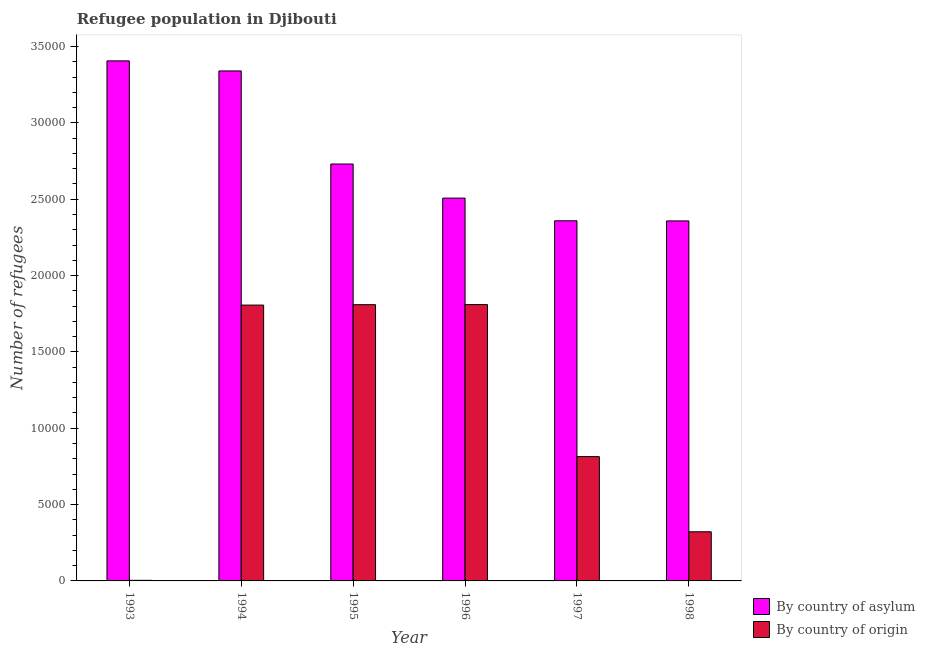How many different coloured bars are there?
Your answer should be compact. 2. Are the number of bars on each tick of the X-axis equal?
Your answer should be compact. Yes. How many bars are there on the 1st tick from the left?
Provide a short and direct response. 2. How many bars are there on the 5th tick from the right?
Give a very brief answer. 2. What is the number of refugees by country of asylum in 1998?
Make the answer very short. 2.36e+04. Across all years, what is the maximum number of refugees by country of origin?
Your response must be concise. 1.81e+04. Across all years, what is the minimum number of refugees by country of asylum?
Keep it short and to the point. 2.36e+04. In which year was the number of refugees by country of asylum minimum?
Offer a very short reply. 1998. What is the total number of refugees by country of asylum in the graph?
Ensure brevity in your answer.  1.67e+05. What is the difference between the number of refugees by country of asylum in 1994 and that in 1996?
Your answer should be compact. 8330. What is the difference between the number of refugees by country of asylum in 1996 and the number of refugees by country of origin in 1998?
Your response must be concise. 1494. What is the average number of refugees by country of asylum per year?
Your response must be concise. 2.78e+04. In the year 1995, what is the difference between the number of refugees by country of asylum and number of refugees by country of origin?
Keep it short and to the point. 0. What is the ratio of the number of refugees by country of asylum in 1996 to that in 1997?
Provide a succinct answer. 1.06. What is the difference between the highest and the second highest number of refugees by country of asylum?
Offer a terse response. 659. What is the difference between the highest and the lowest number of refugees by country of asylum?
Offer a terse response. 1.05e+04. Is the sum of the number of refugees by country of origin in 1995 and 1998 greater than the maximum number of refugees by country of asylum across all years?
Offer a very short reply. Yes. What does the 2nd bar from the left in 1994 represents?
Provide a short and direct response. By country of origin. What does the 1st bar from the right in 1995 represents?
Provide a succinct answer. By country of origin. Where does the legend appear in the graph?
Make the answer very short. Bottom right. How many legend labels are there?
Your answer should be very brief. 2. What is the title of the graph?
Offer a terse response. Refugee population in Djibouti. What is the label or title of the Y-axis?
Your answer should be compact. Number of refugees. What is the Number of refugees in By country of asylum in 1993?
Keep it short and to the point. 3.41e+04. What is the Number of refugees of By country of origin in 1993?
Give a very brief answer. 38. What is the Number of refugees of By country of asylum in 1994?
Ensure brevity in your answer.  3.34e+04. What is the Number of refugees in By country of origin in 1994?
Make the answer very short. 1.81e+04. What is the Number of refugees of By country of asylum in 1995?
Your answer should be very brief. 2.73e+04. What is the Number of refugees in By country of origin in 1995?
Your response must be concise. 1.81e+04. What is the Number of refugees of By country of asylum in 1996?
Provide a short and direct response. 2.51e+04. What is the Number of refugees of By country of origin in 1996?
Make the answer very short. 1.81e+04. What is the Number of refugees of By country of asylum in 1997?
Provide a succinct answer. 2.36e+04. What is the Number of refugees in By country of origin in 1997?
Provide a succinct answer. 8142. What is the Number of refugees of By country of asylum in 1998?
Offer a terse response. 2.36e+04. What is the Number of refugees in By country of origin in 1998?
Offer a terse response. 3219. Across all years, what is the maximum Number of refugees in By country of asylum?
Offer a terse response. 3.41e+04. Across all years, what is the maximum Number of refugees of By country of origin?
Provide a short and direct response. 1.81e+04. Across all years, what is the minimum Number of refugees in By country of asylum?
Your answer should be compact. 2.36e+04. Across all years, what is the minimum Number of refugees in By country of origin?
Your answer should be compact. 38. What is the total Number of refugees in By country of asylum in the graph?
Make the answer very short. 1.67e+05. What is the total Number of refugees of By country of origin in the graph?
Offer a very short reply. 6.57e+04. What is the difference between the Number of refugees in By country of asylum in 1993 and that in 1994?
Provide a short and direct response. 659. What is the difference between the Number of refugees in By country of origin in 1993 and that in 1994?
Provide a succinct answer. -1.80e+04. What is the difference between the Number of refugees of By country of asylum in 1993 and that in 1995?
Provide a short and direct response. 6755. What is the difference between the Number of refugees of By country of origin in 1993 and that in 1995?
Keep it short and to the point. -1.81e+04. What is the difference between the Number of refugees of By country of asylum in 1993 and that in 1996?
Provide a short and direct response. 8989. What is the difference between the Number of refugees in By country of origin in 1993 and that in 1996?
Give a very brief answer. -1.81e+04. What is the difference between the Number of refugees in By country of asylum in 1993 and that in 1997?
Provide a short and direct response. 1.05e+04. What is the difference between the Number of refugees of By country of origin in 1993 and that in 1997?
Your response must be concise. -8104. What is the difference between the Number of refugees in By country of asylum in 1993 and that in 1998?
Offer a very short reply. 1.05e+04. What is the difference between the Number of refugees of By country of origin in 1993 and that in 1998?
Make the answer very short. -3181. What is the difference between the Number of refugees in By country of asylum in 1994 and that in 1995?
Offer a terse response. 6096. What is the difference between the Number of refugees of By country of origin in 1994 and that in 1995?
Keep it short and to the point. -27. What is the difference between the Number of refugees in By country of asylum in 1994 and that in 1996?
Make the answer very short. 8330. What is the difference between the Number of refugees in By country of origin in 1994 and that in 1996?
Provide a succinct answer. -33. What is the difference between the Number of refugees of By country of asylum in 1994 and that in 1997?
Make the answer very short. 9816. What is the difference between the Number of refugees of By country of origin in 1994 and that in 1997?
Provide a short and direct response. 9926. What is the difference between the Number of refugees in By country of asylum in 1994 and that in 1998?
Provide a short and direct response. 9824. What is the difference between the Number of refugees in By country of origin in 1994 and that in 1998?
Ensure brevity in your answer.  1.48e+04. What is the difference between the Number of refugees in By country of asylum in 1995 and that in 1996?
Provide a succinct answer. 2234. What is the difference between the Number of refugees in By country of origin in 1995 and that in 1996?
Your answer should be compact. -6. What is the difference between the Number of refugees of By country of asylum in 1995 and that in 1997?
Keep it short and to the point. 3720. What is the difference between the Number of refugees of By country of origin in 1995 and that in 1997?
Your response must be concise. 9953. What is the difference between the Number of refugees in By country of asylum in 1995 and that in 1998?
Give a very brief answer. 3728. What is the difference between the Number of refugees of By country of origin in 1995 and that in 1998?
Your answer should be compact. 1.49e+04. What is the difference between the Number of refugees in By country of asylum in 1996 and that in 1997?
Provide a succinct answer. 1486. What is the difference between the Number of refugees of By country of origin in 1996 and that in 1997?
Your answer should be compact. 9959. What is the difference between the Number of refugees of By country of asylum in 1996 and that in 1998?
Make the answer very short. 1494. What is the difference between the Number of refugees of By country of origin in 1996 and that in 1998?
Provide a short and direct response. 1.49e+04. What is the difference between the Number of refugees of By country of origin in 1997 and that in 1998?
Provide a short and direct response. 4923. What is the difference between the Number of refugees in By country of asylum in 1993 and the Number of refugees in By country of origin in 1994?
Make the answer very short. 1.60e+04. What is the difference between the Number of refugees of By country of asylum in 1993 and the Number of refugees of By country of origin in 1995?
Offer a very short reply. 1.60e+04. What is the difference between the Number of refugees of By country of asylum in 1993 and the Number of refugees of By country of origin in 1996?
Make the answer very short. 1.60e+04. What is the difference between the Number of refugees of By country of asylum in 1993 and the Number of refugees of By country of origin in 1997?
Give a very brief answer. 2.59e+04. What is the difference between the Number of refugees in By country of asylum in 1993 and the Number of refugees in By country of origin in 1998?
Your answer should be very brief. 3.08e+04. What is the difference between the Number of refugees in By country of asylum in 1994 and the Number of refugees in By country of origin in 1995?
Your response must be concise. 1.53e+04. What is the difference between the Number of refugees of By country of asylum in 1994 and the Number of refugees of By country of origin in 1996?
Your answer should be very brief. 1.53e+04. What is the difference between the Number of refugees in By country of asylum in 1994 and the Number of refugees in By country of origin in 1997?
Provide a succinct answer. 2.53e+04. What is the difference between the Number of refugees in By country of asylum in 1994 and the Number of refugees in By country of origin in 1998?
Offer a very short reply. 3.02e+04. What is the difference between the Number of refugees of By country of asylum in 1995 and the Number of refugees of By country of origin in 1996?
Your response must be concise. 9209. What is the difference between the Number of refugees in By country of asylum in 1995 and the Number of refugees in By country of origin in 1997?
Your response must be concise. 1.92e+04. What is the difference between the Number of refugees of By country of asylum in 1995 and the Number of refugees of By country of origin in 1998?
Provide a succinct answer. 2.41e+04. What is the difference between the Number of refugees in By country of asylum in 1996 and the Number of refugees in By country of origin in 1997?
Provide a short and direct response. 1.69e+04. What is the difference between the Number of refugees of By country of asylum in 1996 and the Number of refugees of By country of origin in 1998?
Provide a succinct answer. 2.19e+04. What is the difference between the Number of refugees in By country of asylum in 1997 and the Number of refugees in By country of origin in 1998?
Give a very brief answer. 2.04e+04. What is the average Number of refugees in By country of asylum per year?
Keep it short and to the point. 2.78e+04. What is the average Number of refugees in By country of origin per year?
Your answer should be compact. 1.09e+04. In the year 1993, what is the difference between the Number of refugees in By country of asylum and Number of refugees in By country of origin?
Your answer should be very brief. 3.40e+04. In the year 1994, what is the difference between the Number of refugees in By country of asylum and Number of refugees in By country of origin?
Ensure brevity in your answer.  1.53e+04. In the year 1995, what is the difference between the Number of refugees in By country of asylum and Number of refugees in By country of origin?
Your answer should be very brief. 9215. In the year 1996, what is the difference between the Number of refugees in By country of asylum and Number of refugees in By country of origin?
Offer a terse response. 6975. In the year 1997, what is the difference between the Number of refugees of By country of asylum and Number of refugees of By country of origin?
Give a very brief answer. 1.54e+04. In the year 1998, what is the difference between the Number of refugees in By country of asylum and Number of refugees in By country of origin?
Give a very brief answer. 2.04e+04. What is the ratio of the Number of refugees in By country of asylum in 1993 to that in 1994?
Make the answer very short. 1.02. What is the ratio of the Number of refugees of By country of origin in 1993 to that in 1994?
Your response must be concise. 0. What is the ratio of the Number of refugees of By country of asylum in 1993 to that in 1995?
Provide a short and direct response. 1.25. What is the ratio of the Number of refugees of By country of origin in 1993 to that in 1995?
Offer a very short reply. 0. What is the ratio of the Number of refugees in By country of asylum in 1993 to that in 1996?
Provide a succinct answer. 1.36. What is the ratio of the Number of refugees of By country of origin in 1993 to that in 1996?
Your answer should be very brief. 0. What is the ratio of the Number of refugees in By country of asylum in 1993 to that in 1997?
Offer a terse response. 1.44. What is the ratio of the Number of refugees in By country of origin in 1993 to that in 1997?
Your response must be concise. 0. What is the ratio of the Number of refugees in By country of asylum in 1993 to that in 1998?
Keep it short and to the point. 1.44. What is the ratio of the Number of refugees of By country of origin in 1993 to that in 1998?
Keep it short and to the point. 0.01. What is the ratio of the Number of refugees in By country of asylum in 1994 to that in 1995?
Your response must be concise. 1.22. What is the ratio of the Number of refugees in By country of asylum in 1994 to that in 1996?
Offer a very short reply. 1.33. What is the ratio of the Number of refugees in By country of asylum in 1994 to that in 1997?
Your answer should be very brief. 1.42. What is the ratio of the Number of refugees in By country of origin in 1994 to that in 1997?
Your response must be concise. 2.22. What is the ratio of the Number of refugees of By country of asylum in 1994 to that in 1998?
Offer a terse response. 1.42. What is the ratio of the Number of refugees of By country of origin in 1994 to that in 1998?
Provide a short and direct response. 5.61. What is the ratio of the Number of refugees in By country of asylum in 1995 to that in 1996?
Give a very brief answer. 1.09. What is the ratio of the Number of refugees of By country of origin in 1995 to that in 1996?
Offer a very short reply. 1. What is the ratio of the Number of refugees of By country of asylum in 1995 to that in 1997?
Provide a succinct answer. 1.16. What is the ratio of the Number of refugees in By country of origin in 1995 to that in 1997?
Your answer should be compact. 2.22. What is the ratio of the Number of refugees of By country of asylum in 1995 to that in 1998?
Keep it short and to the point. 1.16. What is the ratio of the Number of refugees of By country of origin in 1995 to that in 1998?
Make the answer very short. 5.62. What is the ratio of the Number of refugees in By country of asylum in 1996 to that in 1997?
Your response must be concise. 1.06. What is the ratio of the Number of refugees in By country of origin in 1996 to that in 1997?
Your answer should be compact. 2.22. What is the ratio of the Number of refugees of By country of asylum in 1996 to that in 1998?
Your answer should be very brief. 1.06. What is the ratio of the Number of refugees of By country of origin in 1996 to that in 1998?
Give a very brief answer. 5.62. What is the ratio of the Number of refugees of By country of origin in 1997 to that in 1998?
Make the answer very short. 2.53. What is the difference between the highest and the second highest Number of refugees of By country of asylum?
Your answer should be very brief. 659. What is the difference between the highest and the lowest Number of refugees in By country of asylum?
Ensure brevity in your answer.  1.05e+04. What is the difference between the highest and the lowest Number of refugees of By country of origin?
Provide a short and direct response. 1.81e+04. 